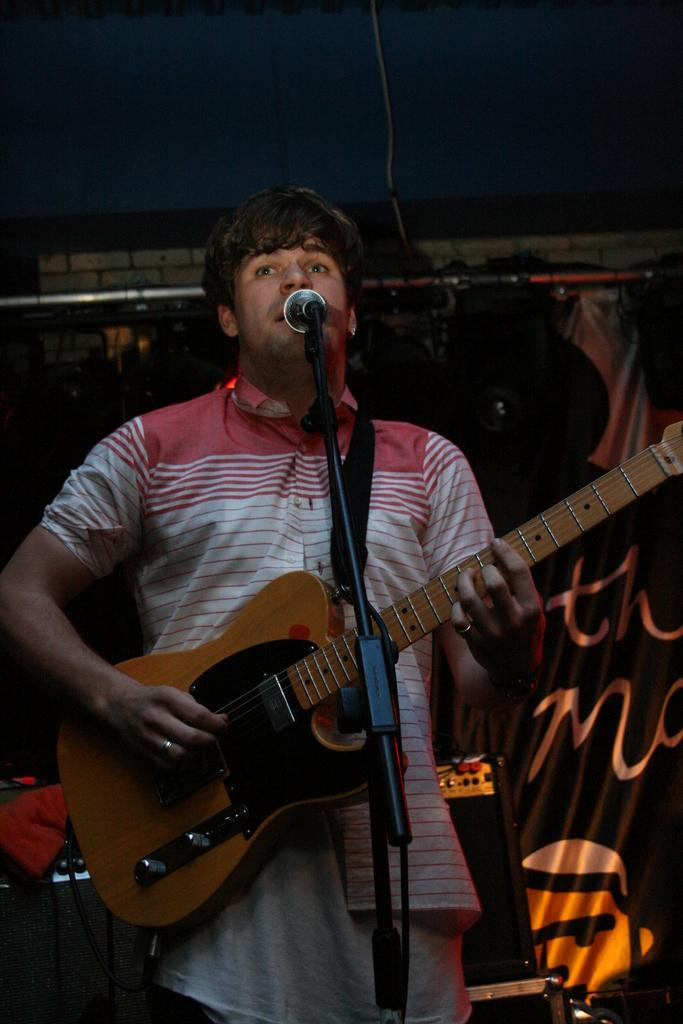What is the person in the image doing? The person is playing a guitar and singing. What object is the person using to amplify their voice? There is a microphone in the image. How many pickles are on the person's head in the image? There are no pickles present in the image. What is the distance between the person and the microphone in the image? The distance between the person and the microphone cannot be determined from the image alone. 